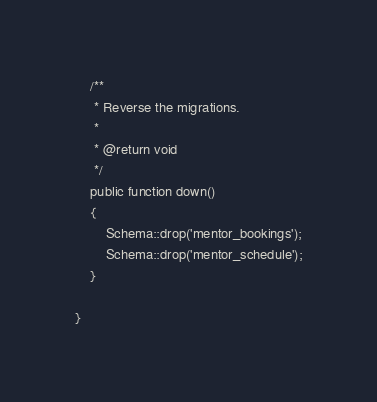<code> <loc_0><loc_0><loc_500><loc_500><_PHP_>
	/**
	 * Reverse the migrations.
	 *
	 * @return void
	 */
	public function down()
	{
		Schema::drop('mentor_bookings');
		Schema::drop('mentor_schedule');
	}

}
</code> 